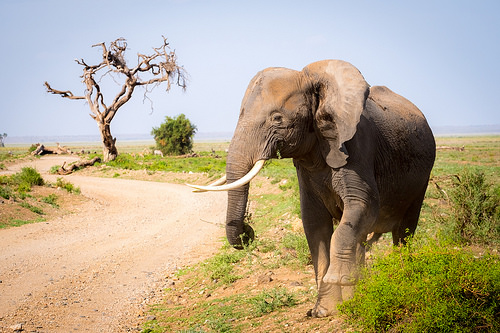<image>
Is there a elephant on the sky? No. The elephant is not positioned on the sky. They may be near each other, but the elephant is not supported by or resting on top of the sky. Is there a elephant under the tree? No. The elephant is not positioned under the tree. The vertical relationship between these objects is different. Is the elephant in front of the tree? Yes. The elephant is positioned in front of the tree, appearing closer to the camera viewpoint. 